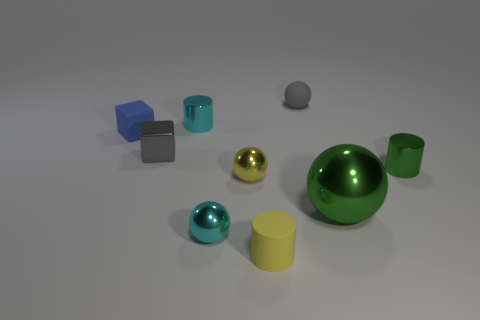Subtract all tiny balls. How many balls are left? 1 Add 1 tiny gray balls. How many objects exist? 10 Subtract all cylinders. How many objects are left? 6 Subtract 4 spheres. How many spheres are left? 0 Subtract all cyan spheres. How many spheres are left? 3 Subtract all yellow cubes. Subtract all purple balls. How many cubes are left? 2 Subtract all metallic cubes. Subtract all small gray matte objects. How many objects are left? 7 Add 8 rubber balls. How many rubber balls are left? 9 Add 7 green things. How many green things exist? 9 Subtract 1 yellow cylinders. How many objects are left? 8 